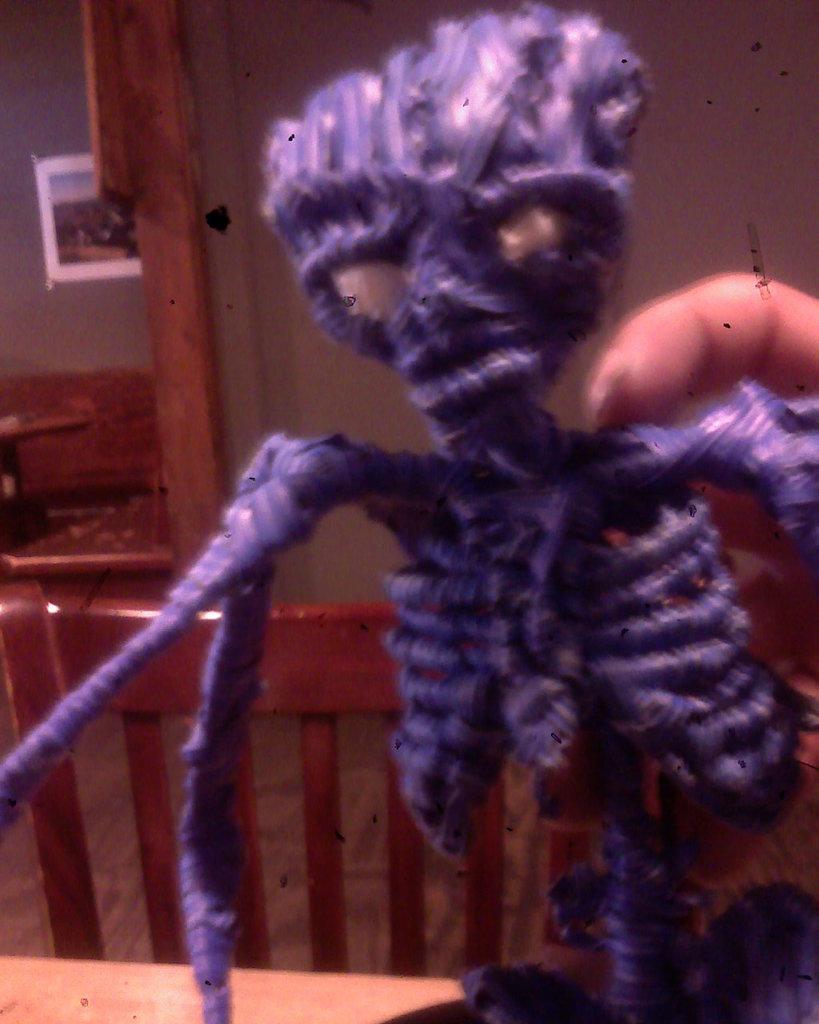Describe this image in one or two sentences. In this picture I can see the toy. 